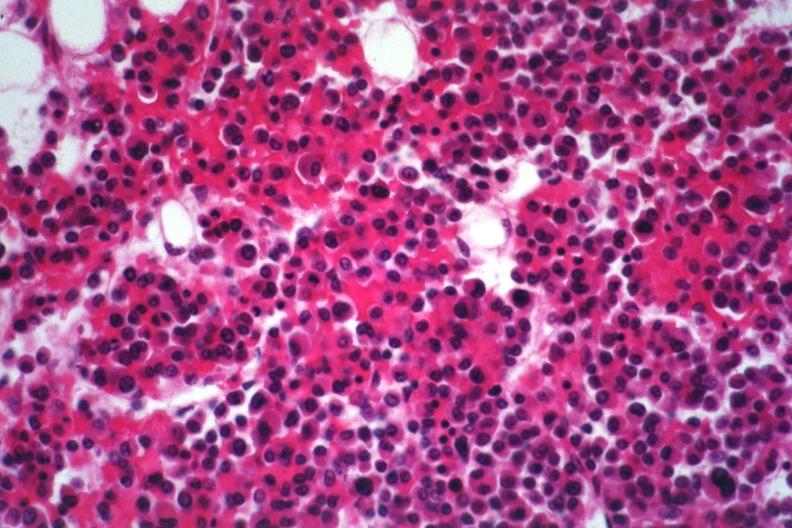s bone marrow present?
Answer the question using a single word or phrase. Yes 